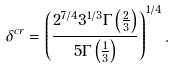Convert formula to latex. <formula><loc_0><loc_0><loc_500><loc_500>\delta ^ { c r } = \left ( \frac { 2 ^ { 7 / 4 } 3 ^ { 1 / 3 } \Gamma \left ( \frac { 2 } { 3 } \right ) } { 5 \Gamma \left ( \frac { 1 } { 3 } \right ) } \right ) ^ { 1 / 4 } .</formula> 